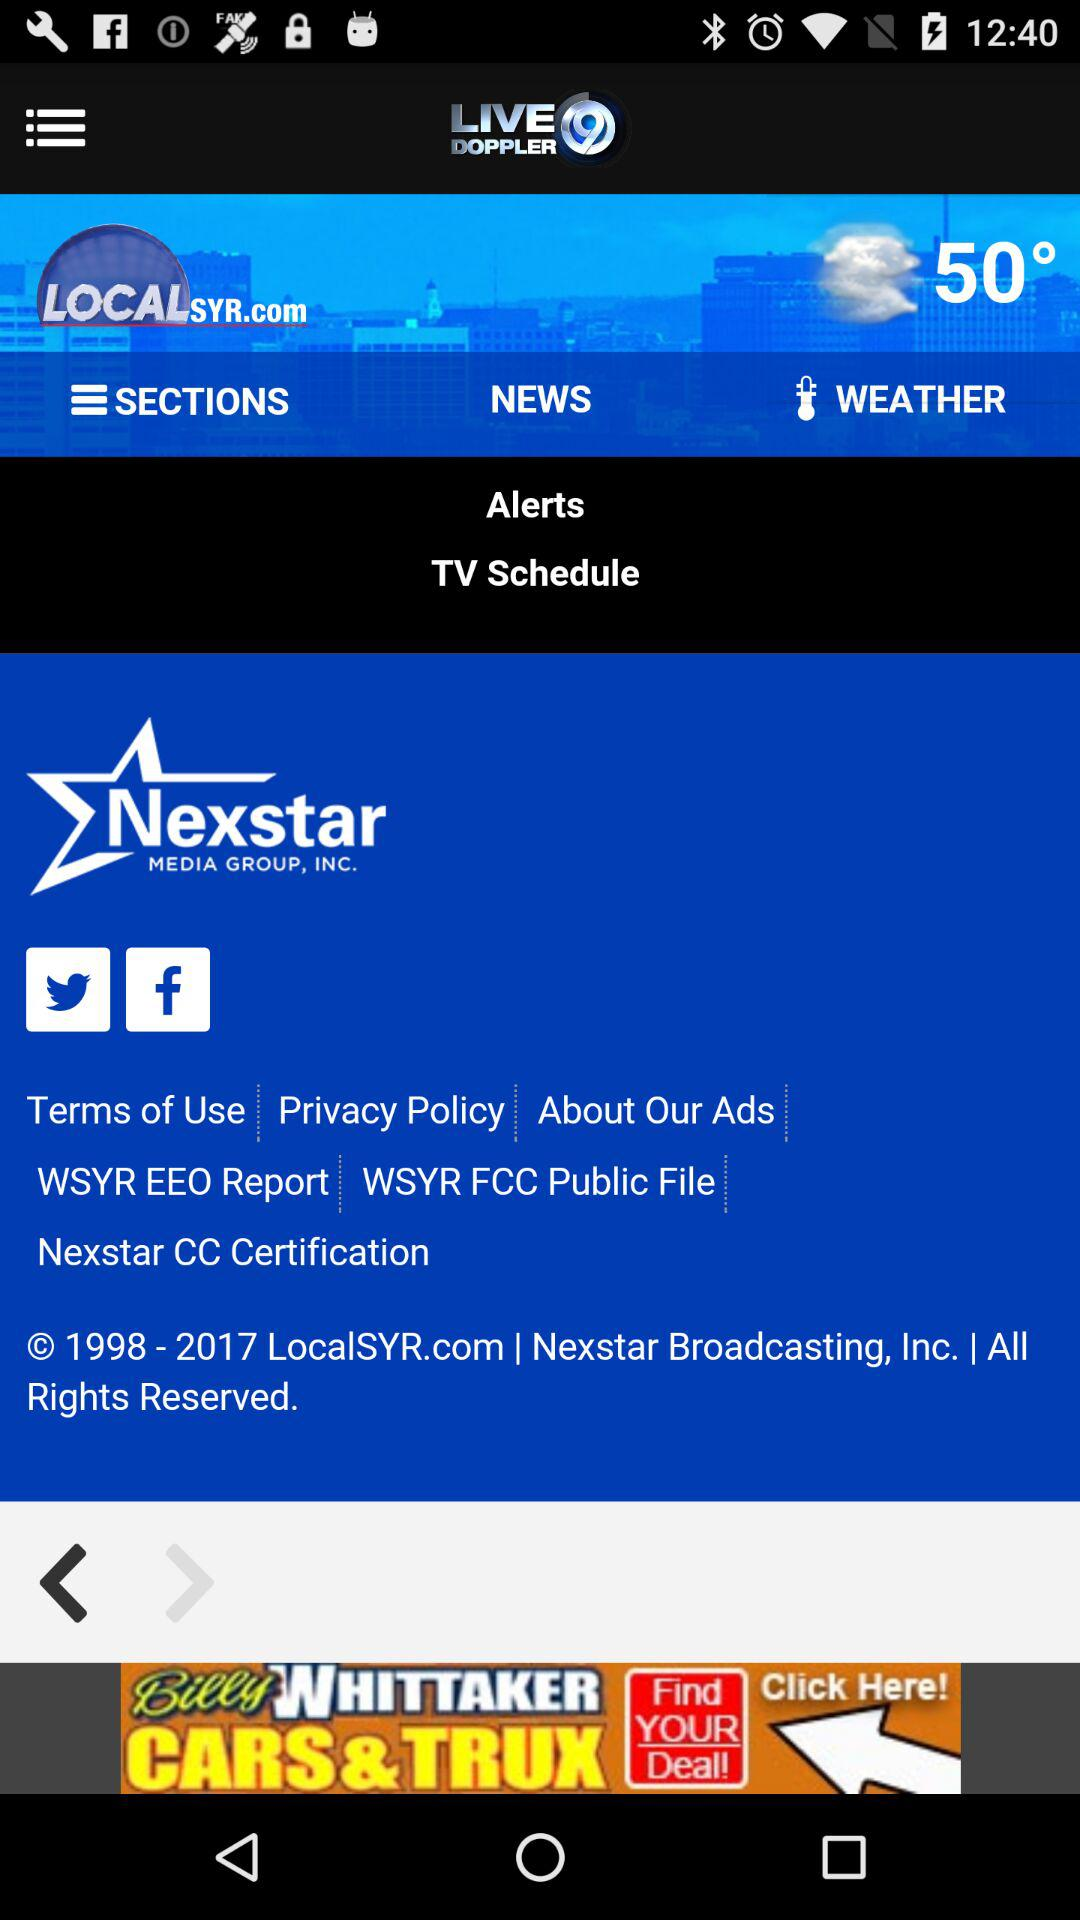What is the application name? The application name is "LIVEDOPPLER9". 